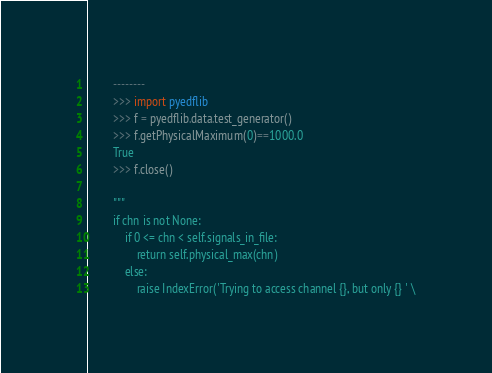Convert code to text. <code><loc_0><loc_0><loc_500><loc_500><_Python_>        --------
        >>> import pyedflib
        >>> f = pyedflib.data.test_generator()
        >>> f.getPhysicalMaximum(0)==1000.0
        True
        >>> f.close()

        """
        if chn is not None:
            if 0 <= chn < self.signals_in_file:
                return self.physical_max(chn)
            else:
                raise IndexError('Trying to access channel {}, but only {} ' \</code> 